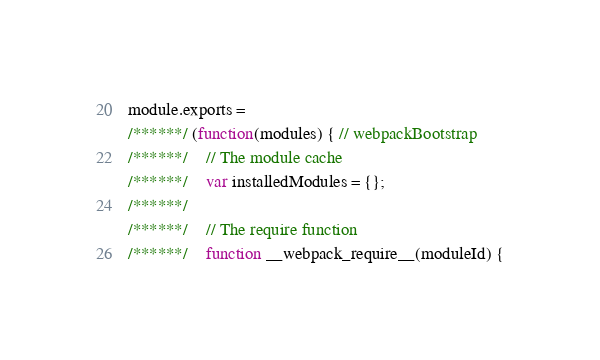<code> <loc_0><loc_0><loc_500><loc_500><_JavaScript_>module.exports =
/******/ (function(modules) { // webpackBootstrap
/******/ 	// The module cache
/******/ 	var installedModules = {};
/******/
/******/ 	// The require function
/******/ 	function __webpack_require__(moduleId) {</code> 